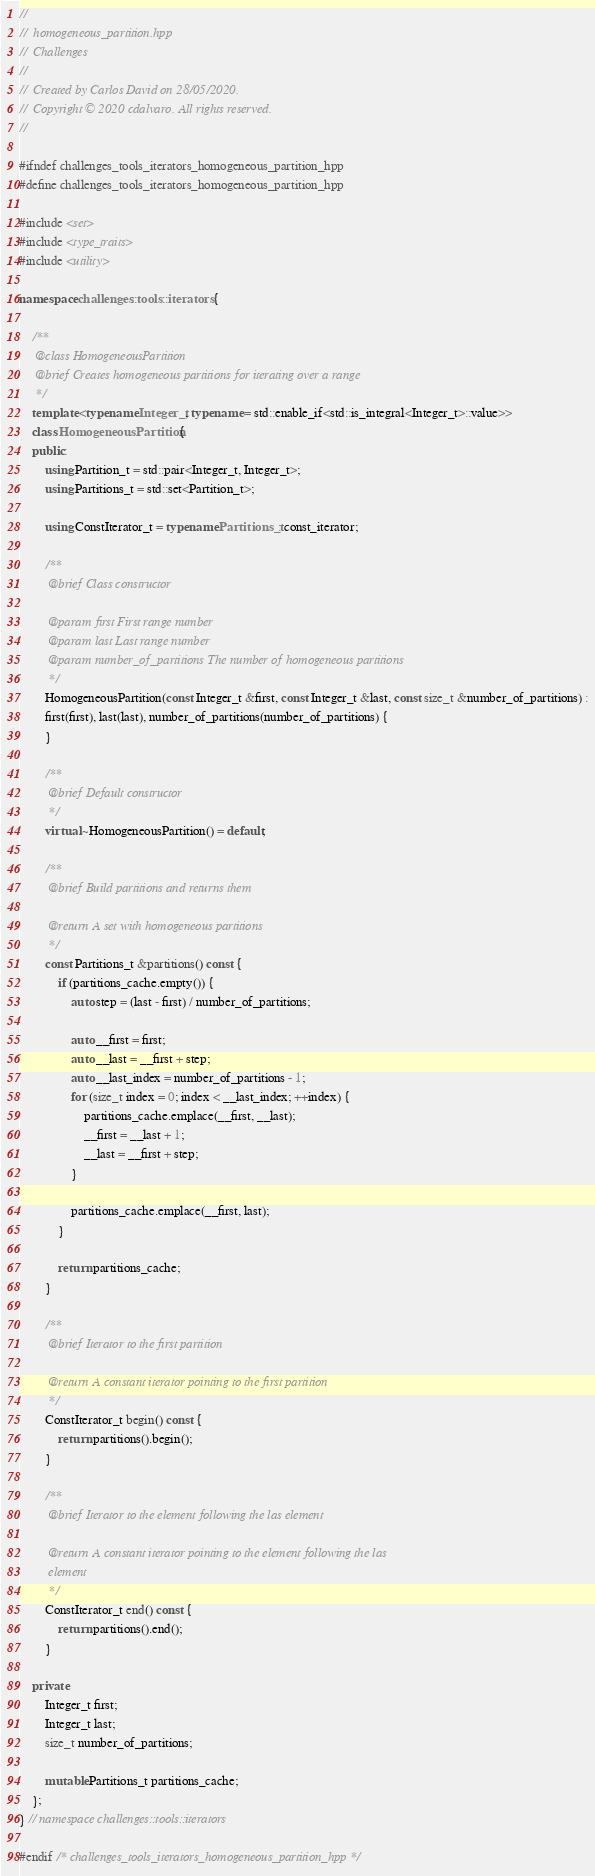<code> <loc_0><loc_0><loc_500><loc_500><_C++_>//
//  homogeneous_partition.hpp
//  Challenges
//
//  Created by Carlos David on 28/05/2020.
//  Copyright © 2020 cdalvaro. All rights reserved.
//

#ifndef challenges_tools_iterators_homogeneous_partition_hpp
#define challenges_tools_iterators_homogeneous_partition_hpp

#include <set>
#include <type_traits>
#include <utility>

namespace challenges::tools::iterators {

    /**
     @class HomogeneousPartition
     @brief Creates homogeneous partitions for iterating over a range
     */
    template <typename Integer_t, typename = std::enable_if<std::is_integral<Integer_t>::value>>
    class HomogeneousPartition {
    public:
        using Partition_t = std::pair<Integer_t, Integer_t>;
        using Partitions_t = std::set<Partition_t>;

        using ConstIterator_t = typename Partitions_t::const_iterator;

        /**
         @brief Class constructor

         @param first First range number
         @param last Last range number
         @param number_of_partitions The number of homogeneous partitions
         */
        HomogeneousPartition(const Integer_t &first, const Integer_t &last, const size_t &number_of_partitions) :
        first(first), last(last), number_of_partitions(number_of_partitions) {
        }

        /**
         @brief Default constructor
         */
        virtual ~HomogeneousPartition() = default;

        /**
         @brief Build partitions and returns them

         @return A set with homogeneous partitions
         */
        const Partitions_t &partitions() const {
            if (partitions_cache.empty()) {
                auto step = (last - first) / number_of_partitions;

                auto __first = first;
                auto __last = __first + step;
                auto __last_index = number_of_partitions - 1;
                for (size_t index = 0; index < __last_index; ++index) {
                    partitions_cache.emplace(__first, __last);
                    __first = __last + 1;
                    __last = __first + step;
                }

                partitions_cache.emplace(__first, last);
            }

            return partitions_cache;
        }

        /**
         @brief Iterator to the first partition

         @return A constant iterator pointing to the first partition
         */
        ConstIterator_t begin() const {
            return partitions().begin();
        }

        /**
         @brief Iterator to the element following the las element

         @return A constant iterator pointing to the element following the las
         element
         */
        ConstIterator_t end() const {
            return partitions().end();
        }

    private:
        Integer_t first;
        Integer_t last;
        size_t number_of_partitions;

        mutable Partitions_t partitions_cache;
    };
} // namespace challenges::tools::iterators

#endif /* challenges_tools_iterators_homogeneous_partition_hpp */
</code> 